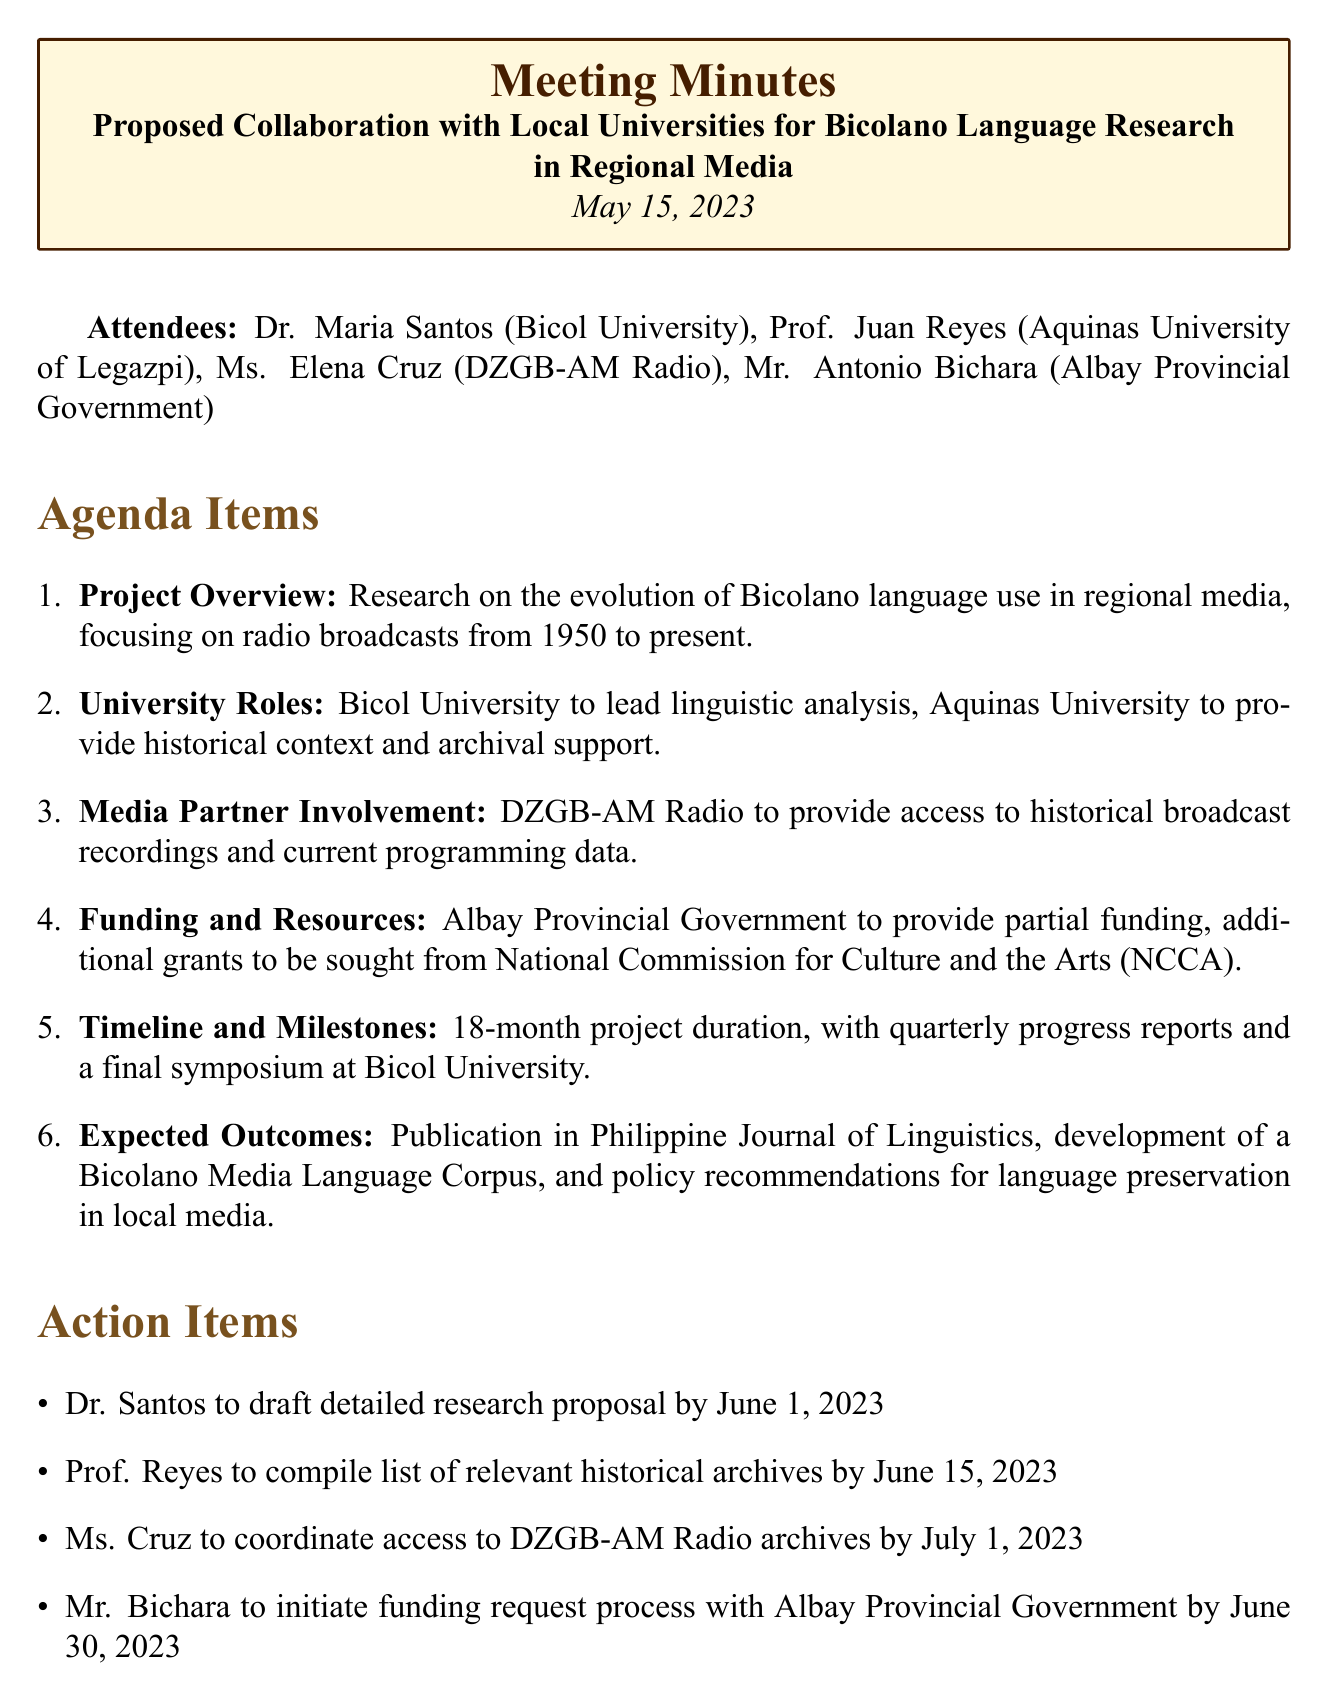What is the date of the meeting? The date of the meeting is clearly stated in the document as May 15, 2023.
Answer: May 15, 2023 Who is responsible for the linguistic analysis? The document specifies that Bicol University is to lead the linguistic analysis in the project.
Answer: Bicol University What is the duration of the project? The document mentions that the project has an 18-month duration.
Answer: 18 months Which organization is expected to provide partial funding? The document indicates that the Albay Provincial Government will provide partial funding for the project.
Answer: Albay Provincial Government What is one of the expected outcomes of the research? The document lists several expected outcomes, one of which is publication in the Philippine Journal of Linguistics.
Answer: Publication in Philippine Journal of Linguistics By when is Dr. Santos expected to draft the proposal? According to the action items, Dr. Santos has a deadline of June 1, 2023, to draft the detailed research proposal.
Answer: June 1, 2023 How many attendees were at the meeting? The document lists four attendees, which counts the participants of the meeting.
Answer: Four What is one of the roles of Aquinas University in the project? The document states that Aquinas University is to provide historical context and archival support.
Answer: Provide historical context and archival support What is the final event planned for the project? The document mentions that a final symposium is scheduled at Bicol University at the end of the project.
Answer: Final symposium at Bicol University 